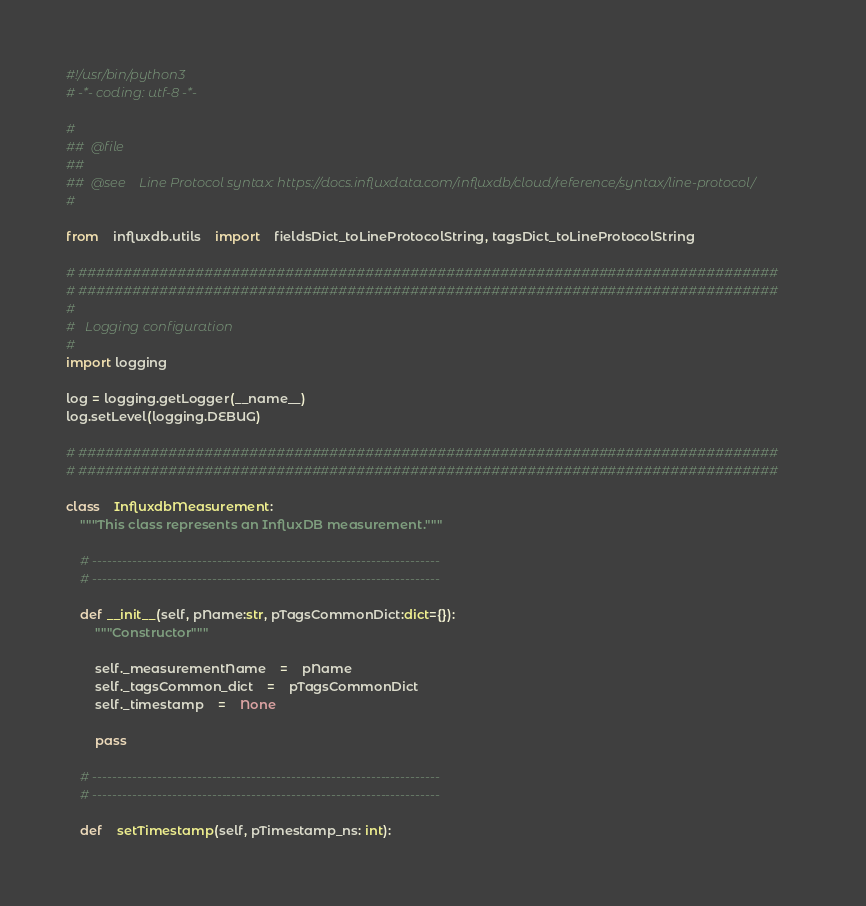<code> <loc_0><loc_0><loc_500><loc_500><_Python_>#!/usr/bin/python3
# -*- coding: utf-8 -*-

#
##  @file
##
##  @see    Line Protocol syntax: https://docs.influxdata.com/influxdb/cloud/reference/syntax/line-protocol/
#

from	influxdb.utils	import	fieldsDict_toLineProtocolString, tagsDict_toLineProtocolString

# ##############################################################################
# ##############################################################################
#
#	Logging configuration
#
import logging

log = logging.getLogger(__name__)
log.setLevel(logging.DEBUG)

# ##############################################################################
# ##############################################################################

class	InfluxdbMeasurement:
	"""This class represents an InfluxDB measurement."""

	# ----------------------------------------------------------------------
	# ----------------------------------------------------------------------

	def __init__(self, pName:str, pTagsCommonDict:dict={}):
		"""Constructor"""

		self._measurementName	=	pName
		self._tagsCommon_dict	=	pTagsCommonDict
		self._timestamp	=	None

		pass

	# ----------------------------------------------------------------------
	# ----------------------------------------------------------------------

	def	setTimestamp(self, pTimestamp_ns: int):</code> 